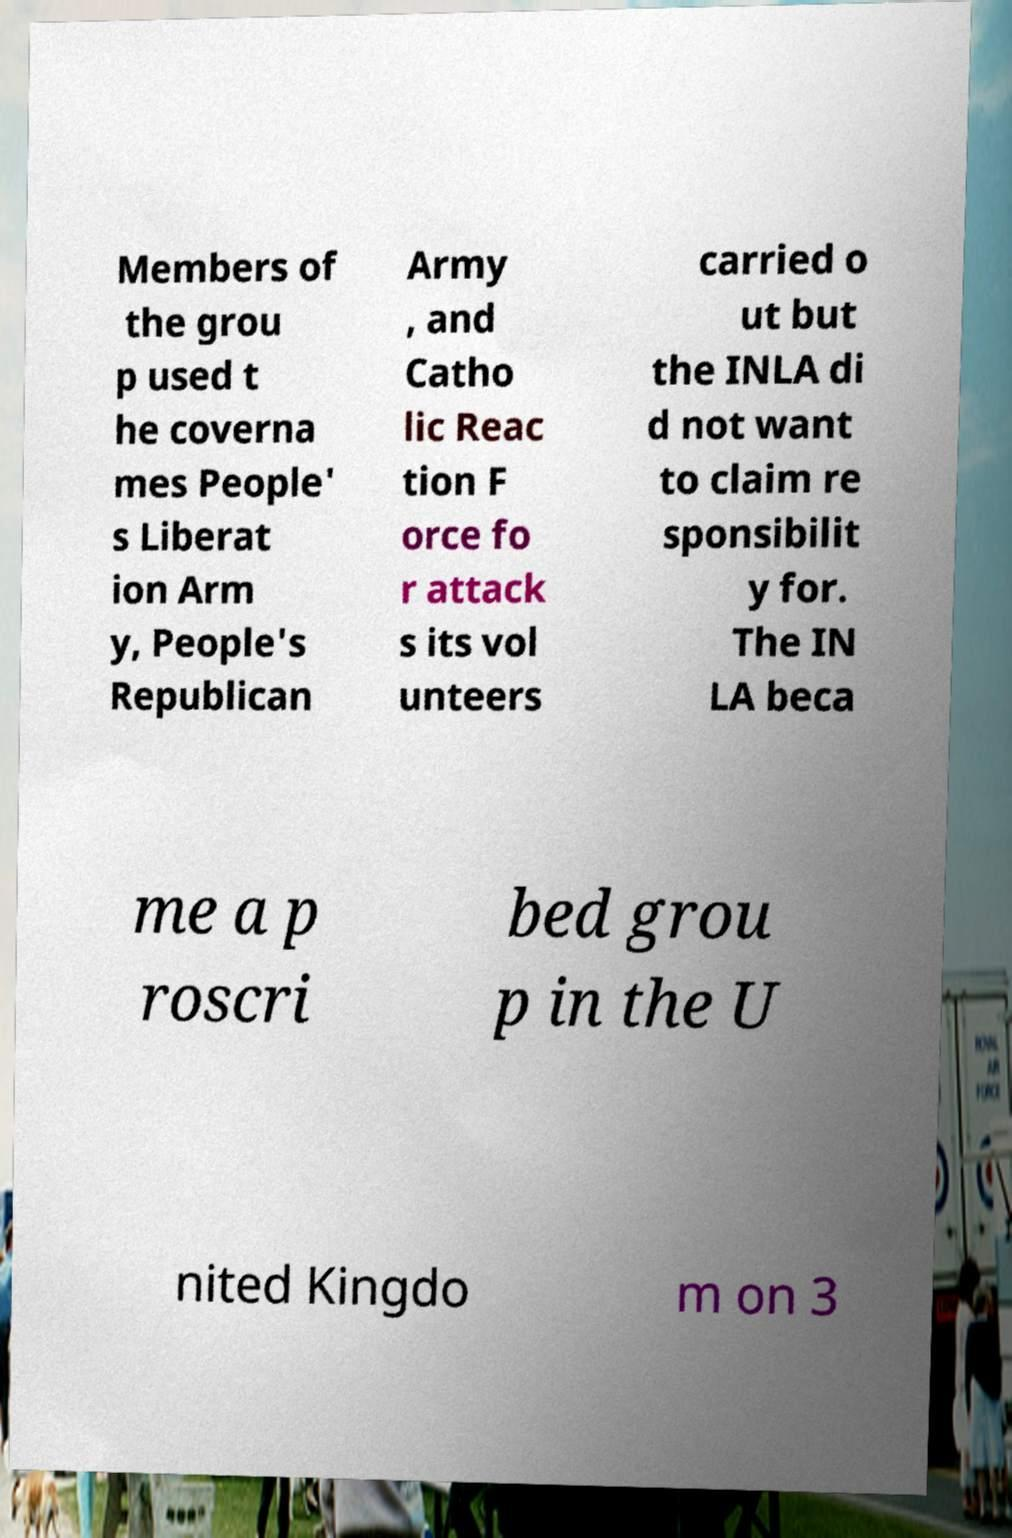Could you assist in decoding the text presented in this image and type it out clearly? Members of the grou p used t he coverna mes People' s Liberat ion Arm y, People's Republican Army , and Catho lic Reac tion F orce fo r attack s its vol unteers carried o ut but the INLA di d not want to claim re sponsibilit y for. The IN LA beca me a p roscri bed grou p in the U nited Kingdo m on 3 